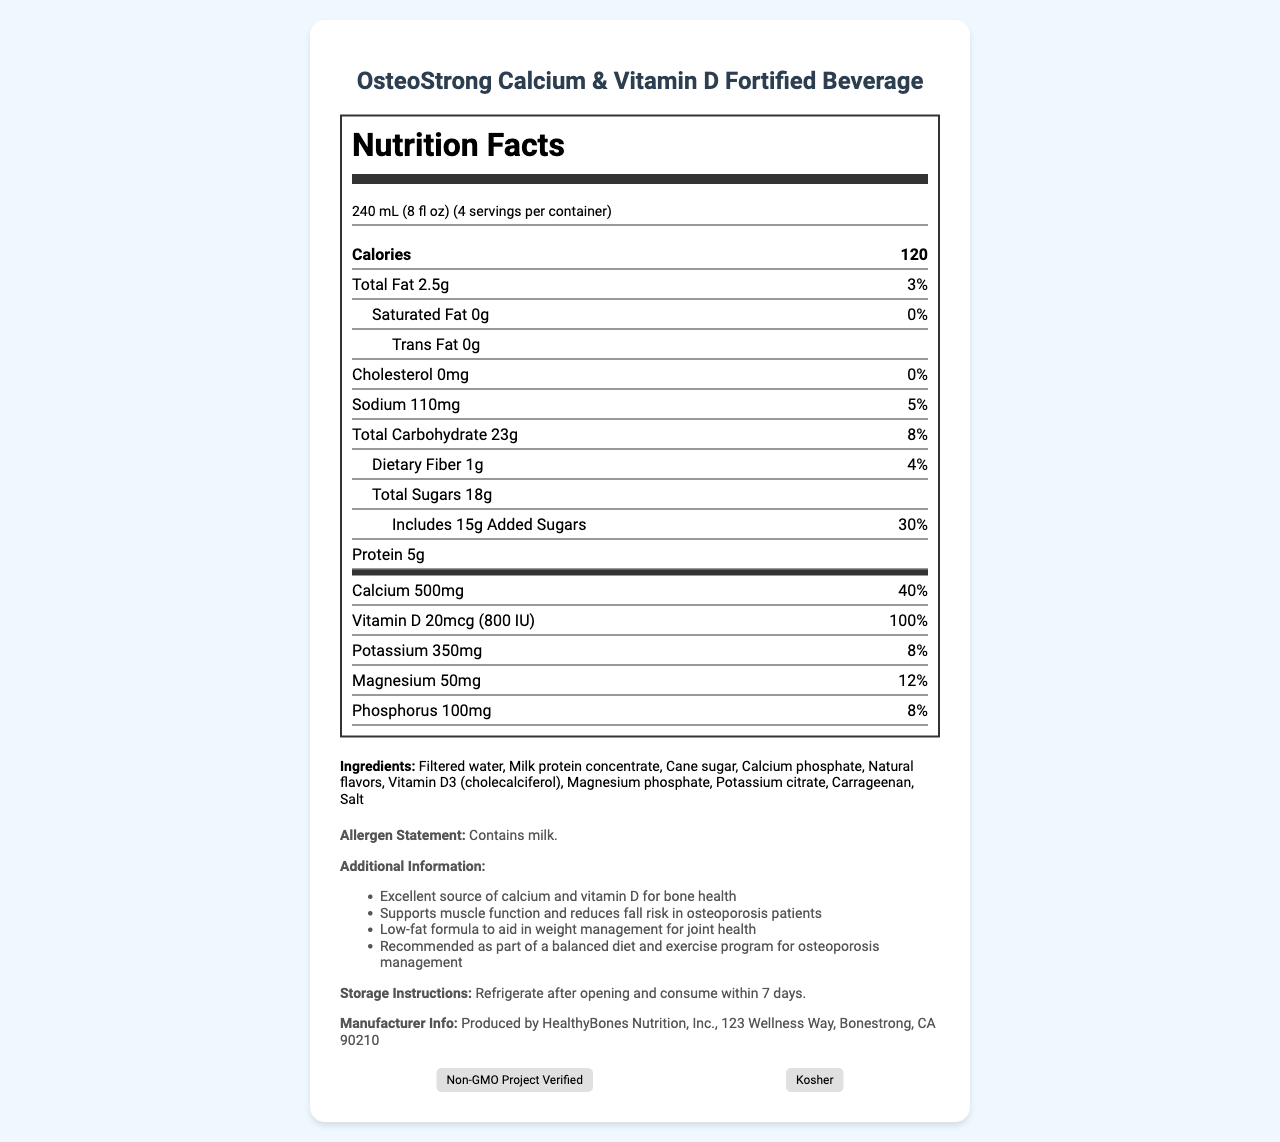what is the product name? The product name is clearly mentioned at the top of the document.
Answer: OsteoStrong Calcium & Vitamin D Fortified Beverage how many servings are in a container? The servings per container are listed as 4.
Answer: 4 how many calories are there per serving? The document lists 120 calories per serving.
Answer: 120 what is the amount of calcium per serving? The amount of calcium per serving is indicated as 500mg.
Answer: 500mg which nutrient has the highest daily value percentage? The daily value percentage for Vitamin D is 100%, which is higher than any other nutrient listed.
Answer: Vitamin D: 100% how much total fat is in one serving? The total fat per serving is listed as 2.5g.
Answer: 2.5g what is the daily value percentage of sodium per serving? The daily value percentage of sodium per serving is indicated as 5%.
Answer: 5% what is the fiber content in the beverage? The fiber content per serving is listed as 1g.
Answer: 1g how much protein does the beverage contain per serving? A. 8g B. 3g C. 5g D. 2g According to the document, each serving contains 5g of protein.
Answer: C. 5g what is the saturated fat content per serving? I. 0g II. 5g III. 2g IV. 10g The document states that the saturated fat content per serving is 0g.
Answer: I. 0g does the beverage contain any cholesterol? The beverage has 0mg of cholesterol, as mentioned in the document.
Answer: No is the beverage an excellent source of calcium and vitamin D for bone health? The additional information section states that the beverage is an excellent source of calcium and vitamin D for bone health.
Answer: Yes what is the main idea of the document? The document includes nutrition details, ingredients, allergen statements, storage instructions, and certifications, emphasizing the beverage's benefits for bone health and muscle function in osteoporosis patients.
Answer: The document provides detailed nutrition facts and additional information about the OsteoStrong Calcium & Vitamin D Fortified Beverage, highlighting its benefits for osteoporosis patients. how long can the beverage be stored after opening? The storage instructions mention to refrigerate after opening and consume within 7 days.
Answer: 7 days what certifications does the product have? A. Gluten-Free B. Non-GMO C. Organic D. Kosher E. Vegan The certifications listed are Non-GMO Project Verified and Kosher.
Answer: B. Non-GMO, D. Kosher who is the manufacturer of this beverage? The document specifies that the beverage is produced by HealthyBones Nutrition, Inc.
Answer: HealthyBones Nutrition, Inc. what is the exact address of the manufacturer? The manufacturer's address is given as 123 Wellness Way, Bonestrong, CA 90210.
Answer: 123 Wellness Way, Bonestrong, CA 90210 how does the beverage aid in weight management? The additional information mentions that the beverage has a low-fat formula to aid in weight management for joint health.
Answer: Low-fat formula what type of vitamin D is used in the beverage? The document lists Vitamin D3 (cholecalciferol) among the ingredients.
Answer: Vitamin D3 (cholecalciferol) how much magnesium is in one serving? The magnesium content per serving is indicated as 50mg.
Answer: 50mg does the document provide information about the price of the product? The document does not include any pricing information about the product.
Answer: Not enough information 